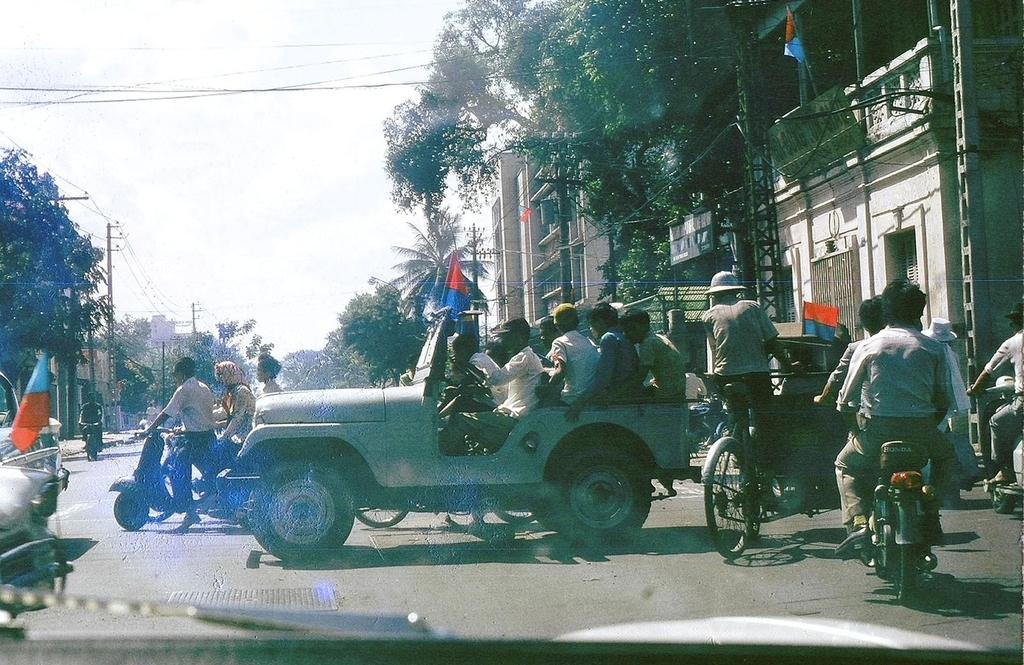What is happening on the road in the image? Vehicles are moving on the road. What can be seen on both sides of the road? There are trees and buildings on either side of the road. What else is present on both sides of the road? Electrical poles are present on either side of the road. Can you see any steam coming from the vehicles in the image? There is no mention of steam in the image, so it cannot be determined if steam is present. 